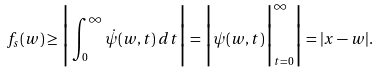Convert formula to latex. <formula><loc_0><loc_0><loc_500><loc_500>f _ { s } ( w ) \geq \Big | \int _ { 0 } ^ { \infty } \dot { \psi } ( w , t ) \, d t \Big | = \Big | \psi ( w , t ) \Big | _ { t = 0 } ^ { \infty } \Big | = | x - w | .</formula> 